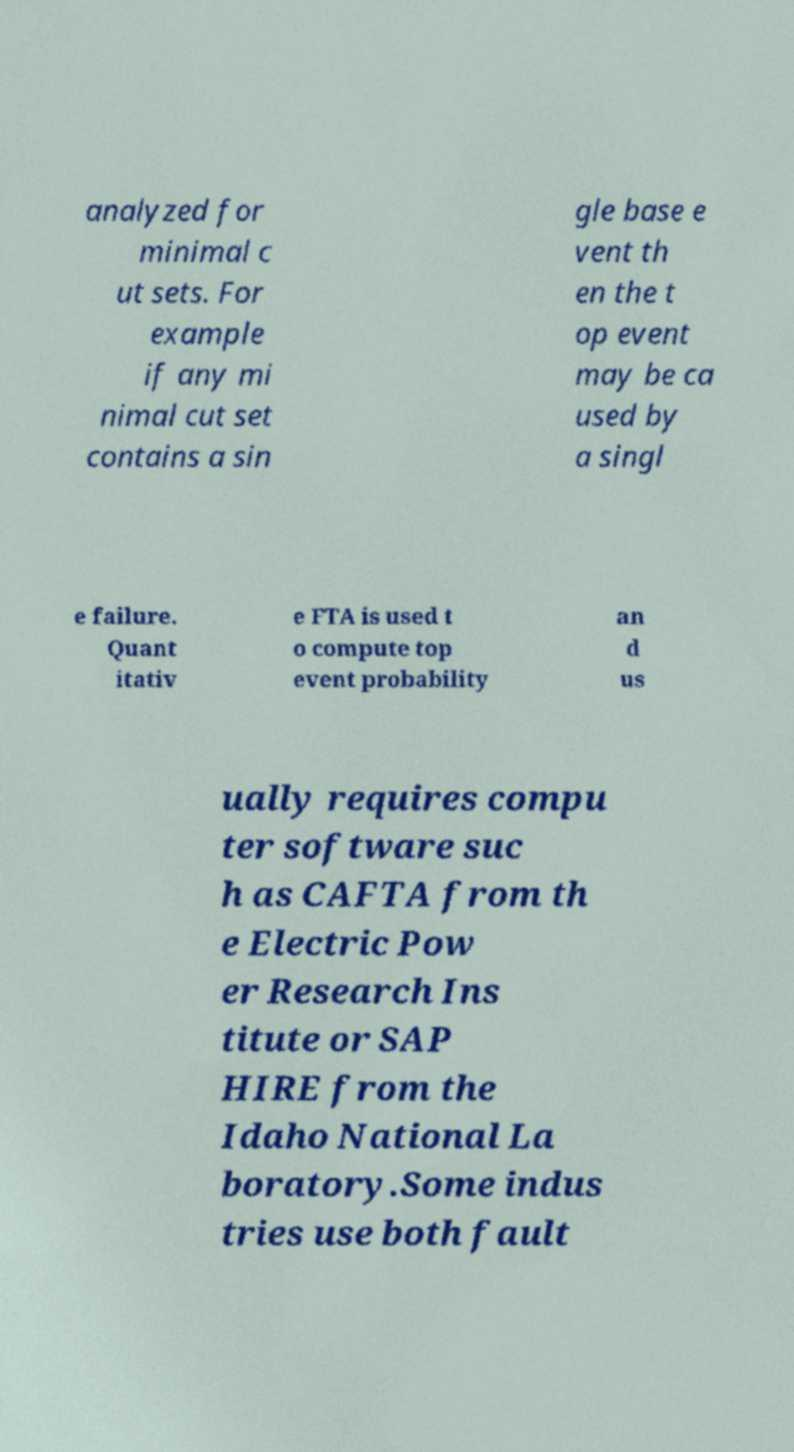What messages or text are displayed in this image? I need them in a readable, typed format. analyzed for minimal c ut sets. For example if any mi nimal cut set contains a sin gle base e vent th en the t op event may be ca used by a singl e failure. Quant itativ e FTA is used t o compute top event probability an d us ually requires compu ter software suc h as CAFTA from th e Electric Pow er Research Ins titute or SAP HIRE from the Idaho National La boratory.Some indus tries use both fault 